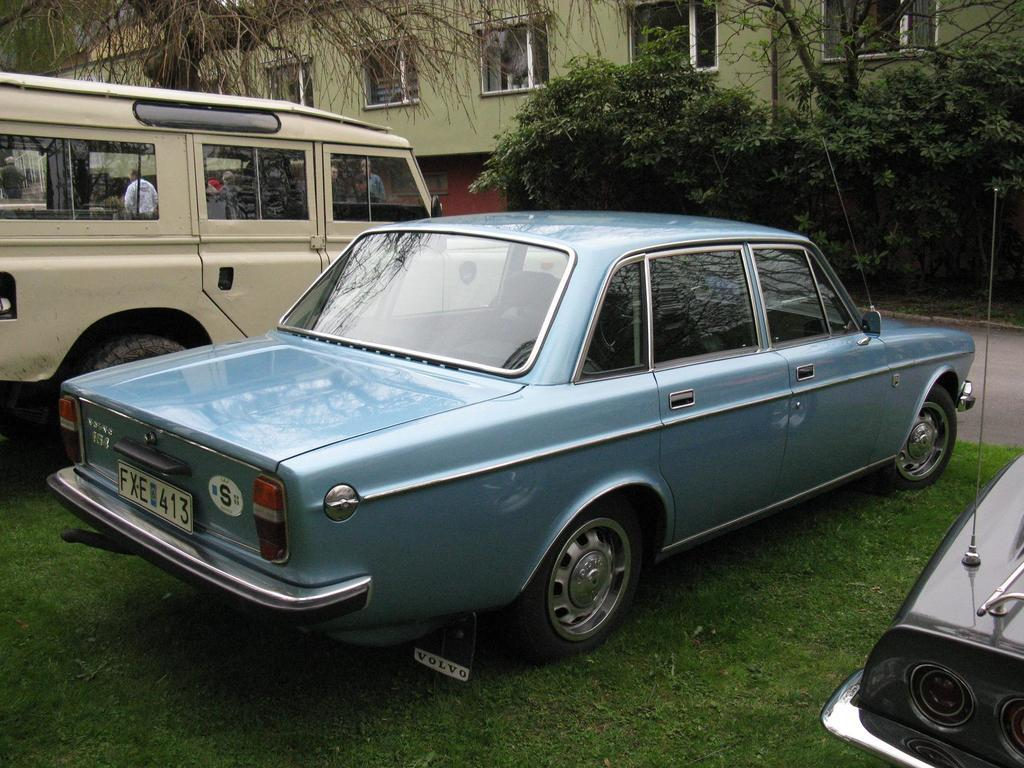Where was the image taken? The image was taken outside. What vehicles can be seen in the middle of the image? There are cars and vans in the middle of the image. What type of natural elements are visible at the top of the image? There are trees at the top of the image. What type of structure is visible at the top of the image? There is a building at the top of the image. Can you see any ears on the trees in the image? There are no ears visible on the trees in the image, as ears are a characteristic of animals and not plants. 